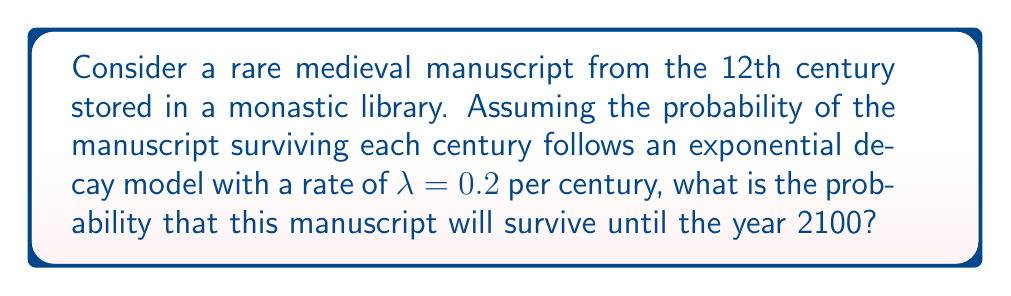Give your solution to this math problem. Let's approach this step-by-step:

1) First, we need to calculate how many centuries have passed from the 12th century to the year 2100.
   - 12th century spans from 1101 to 1200
   - Let's assume the manuscript is from 1150 (middle of the century)
   - From 1150 to 2100 is 950 years
   - 950 years = 9.5 centuries

2) The survival probability follows an exponential decay model. The probability of survival after time t is given by:

   $$P(T > t) = e^{-\lambda t}$$

   where $\lambda$ is the decay rate and $t$ is the time.

3) We are given that $\lambda = 0.2$ per century, and $t = 9.5$ centuries.

4) Plugging these values into our equation:

   $$P(T > 9.5) = e^{-0.2 \cdot 9.5}$$

5) Let's calculate this:
   $$e^{-0.2 \cdot 9.5} = e^{-1.9} \approx 0.1496$$

6) Converting to a percentage: 0.1496 * 100 ≈ 14.96%

Therefore, the probability that the manuscript will survive until the year 2100 is approximately 14.96%.
Answer: 14.96% 